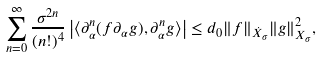<formula> <loc_0><loc_0><loc_500><loc_500>\sum _ { n = 0 } ^ { \infty } \frac { \sigma ^ { 2 n } } { ( n ! ) ^ { 4 } } \left | \langle \partial _ { \alpha } ^ { n } ( f \partial _ { \alpha } g ) , \partial _ { \alpha } ^ { n } g \rangle \right | \leq d _ { 0 } \| f \| _ { \dot { X } _ { \sigma } } \| g \| _ { X _ { \sigma } } ^ { 2 } ,</formula> 